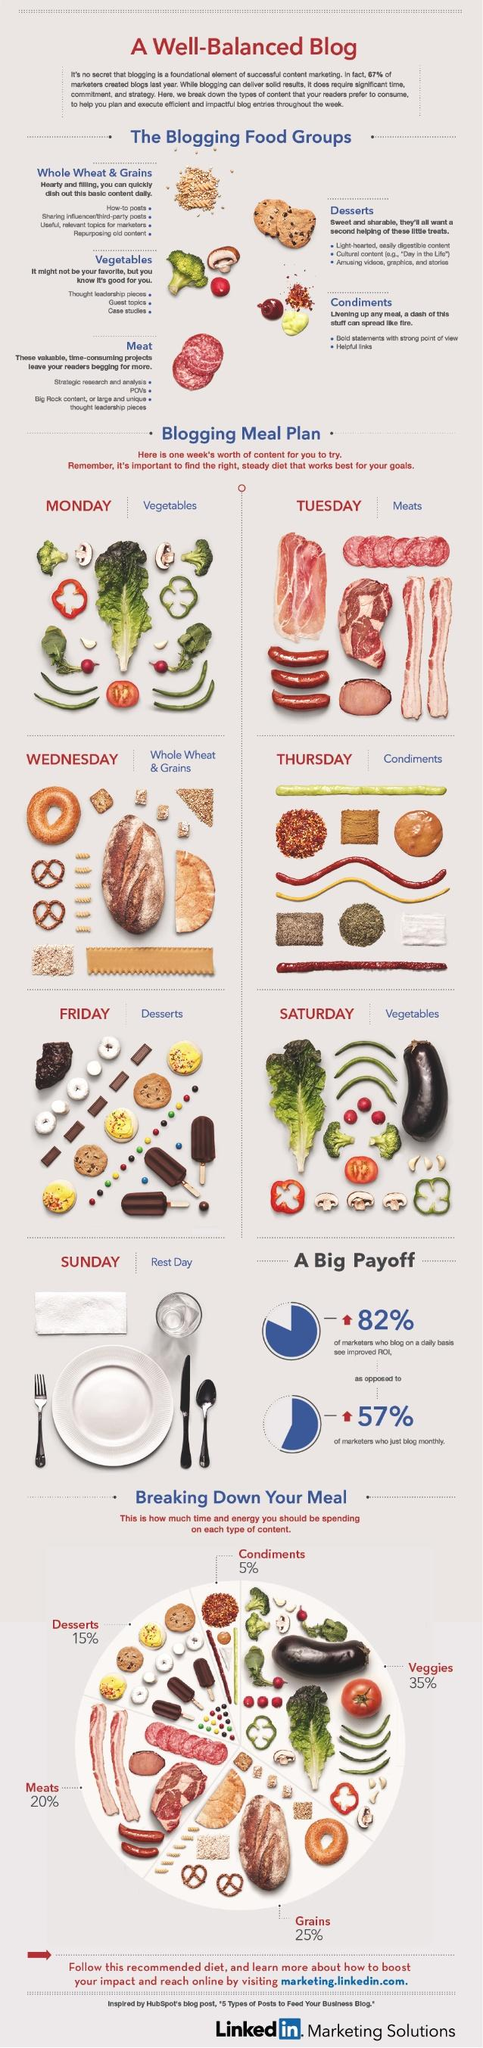Outline some significant characteristics in this image. The infographic lists 6 different varieties of meats. Vegetables have a higher share than grains in terms of calories consumed. There are five food groups mentioned in this infographic. 